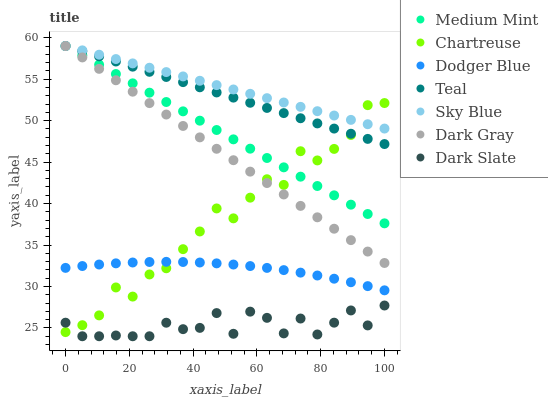Does Dark Slate have the minimum area under the curve?
Answer yes or no. Yes. Does Sky Blue have the maximum area under the curve?
Answer yes or no. Yes. Does Dark Gray have the minimum area under the curve?
Answer yes or no. No. Does Dark Gray have the maximum area under the curve?
Answer yes or no. No. Is Sky Blue the smoothest?
Answer yes or no. Yes. Is Chartreuse the roughest?
Answer yes or no. Yes. Is Dark Gray the smoothest?
Answer yes or no. No. Is Dark Gray the roughest?
Answer yes or no. No. Does Dark Slate have the lowest value?
Answer yes or no. Yes. Does Dark Gray have the lowest value?
Answer yes or no. No. Does Sky Blue have the highest value?
Answer yes or no. Yes. Does Dark Slate have the highest value?
Answer yes or no. No. Is Dodger Blue less than Sky Blue?
Answer yes or no. Yes. Is Medium Mint greater than Dodger Blue?
Answer yes or no. Yes. Does Dodger Blue intersect Chartreuse?
Answer yes or no. Yes. Is Dodger Blue less than Chartreuse?
Answer yes or no. No. Is Dodger Blue greater than Chartreuse?
Answer yes or no. No. Does Dodger Blue intersect Sky Blue?
Answer yes or no. No. 